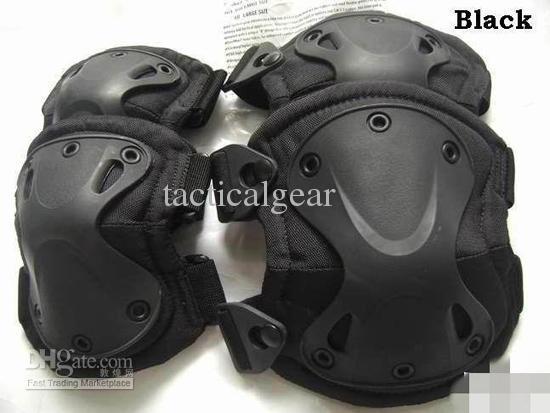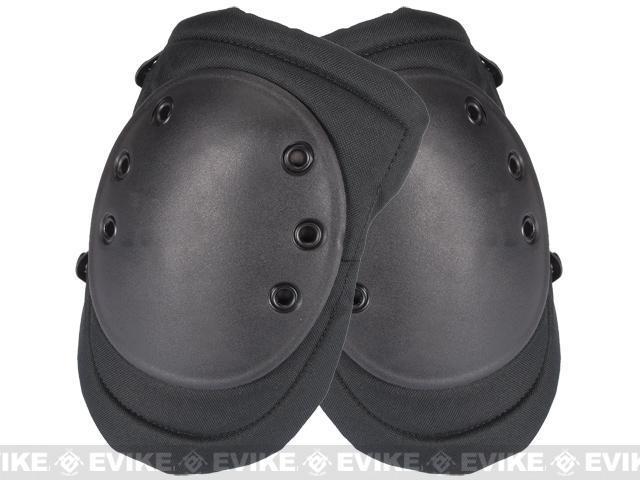The first image is the image on the left, the second image is the image on the right. For the images shown, is this caption "There are three greyish colored pads." true? Answer yes or no. No. The first image is the image on the left, the second image is the image on the right. For the images displayed, is the sentence "The left image contains one kneepad, while the right image contains a pair." factually correct? Answer yes or no. No. 